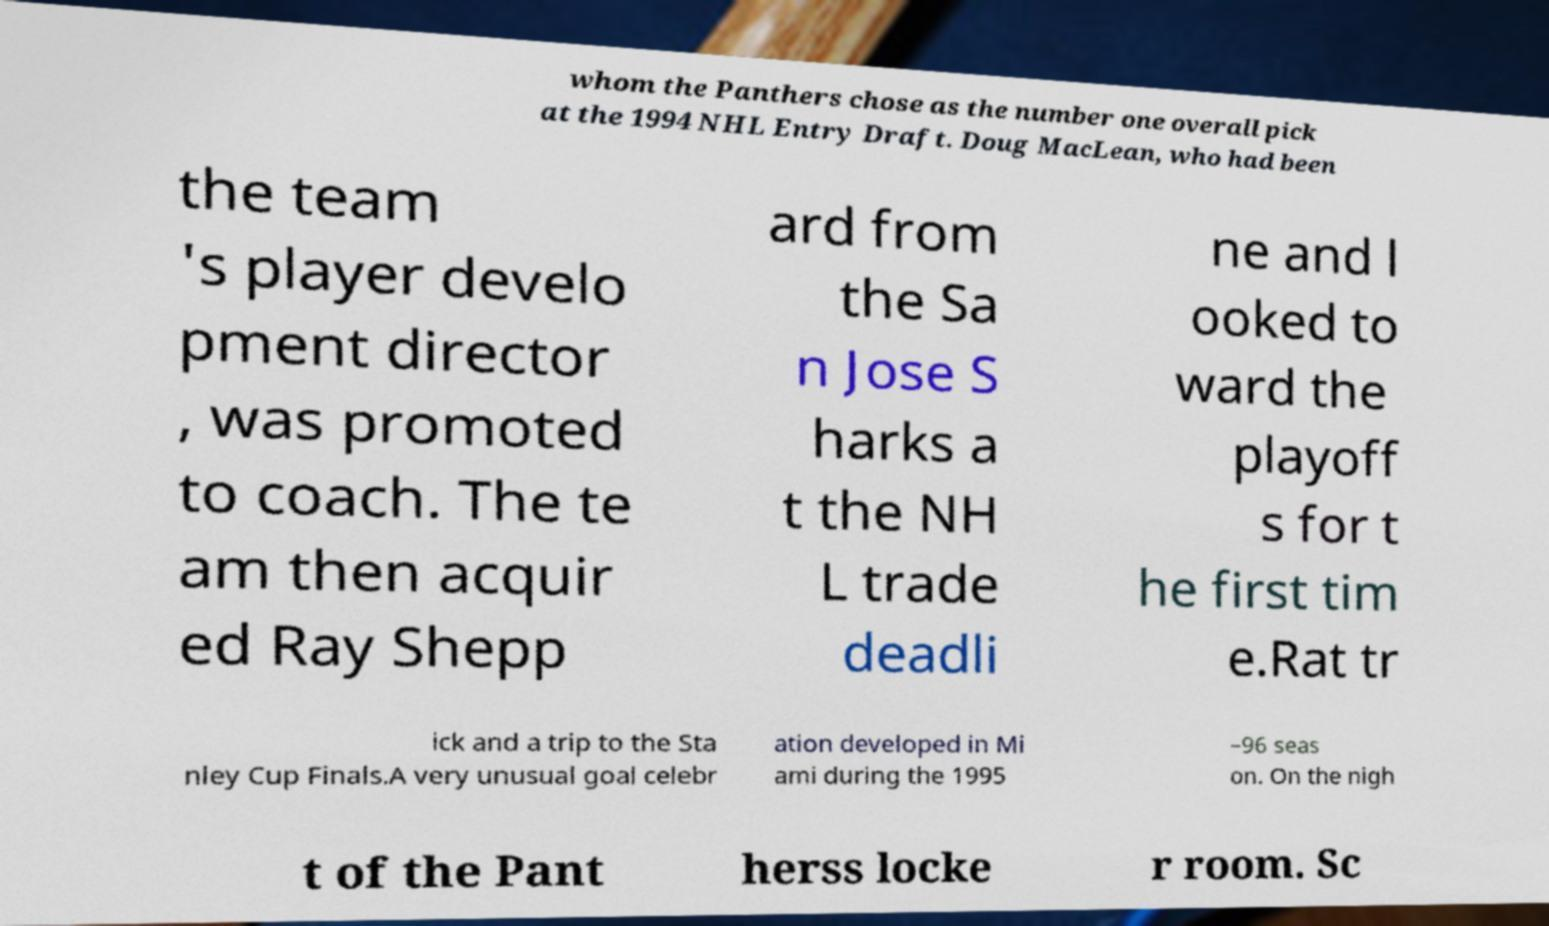What messages or text are displayed in this image? I need them in a readable, typed format. whom the Panthers chose as the number one overall pick at the 1994 NHL Entry Draft. Doug MacLean, who had been the team 's player develo pment director , was promoted to coach. The te am then acquir ed Ray Shepp ard from the Sa n Jose S harks a t the NH L trade deadli ne and l ooked to ward the playoff s for t he first tim e.Rat tr ick and a trip to the Sta nley Cup Finals.A very unusual goal celebr ation developed in Mi ami during the 1995 –96 seas on. On the nigh t of the Pant herss locke r room. Sc 